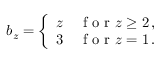Convert formula to latex. <formula><loc_0><loc_0><loc_500><loc_500>\begin{array} { r } { b _ { z } = \left \{ \begin{array} { l l } { z } & { f o r z \geq 2 \, , } \\ { 3 } & { f o r z = 1 \, . } \end{array} } \end{array}</formula> 